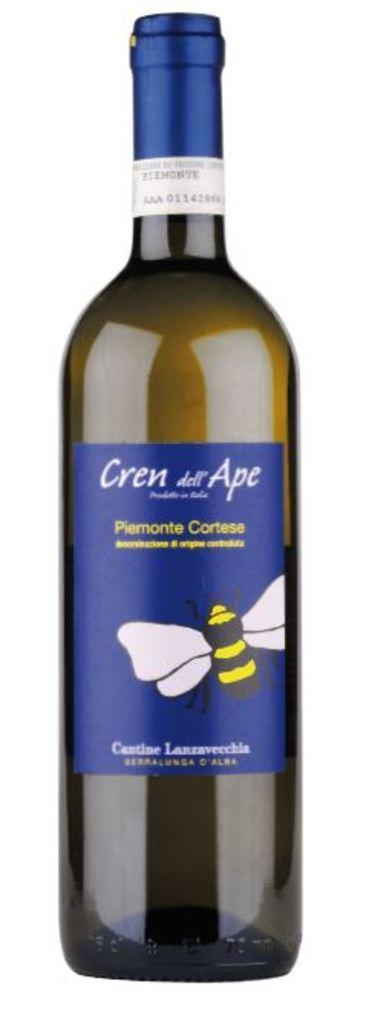Please provide a concise description of this image. In this image i can see a glass bottle. 